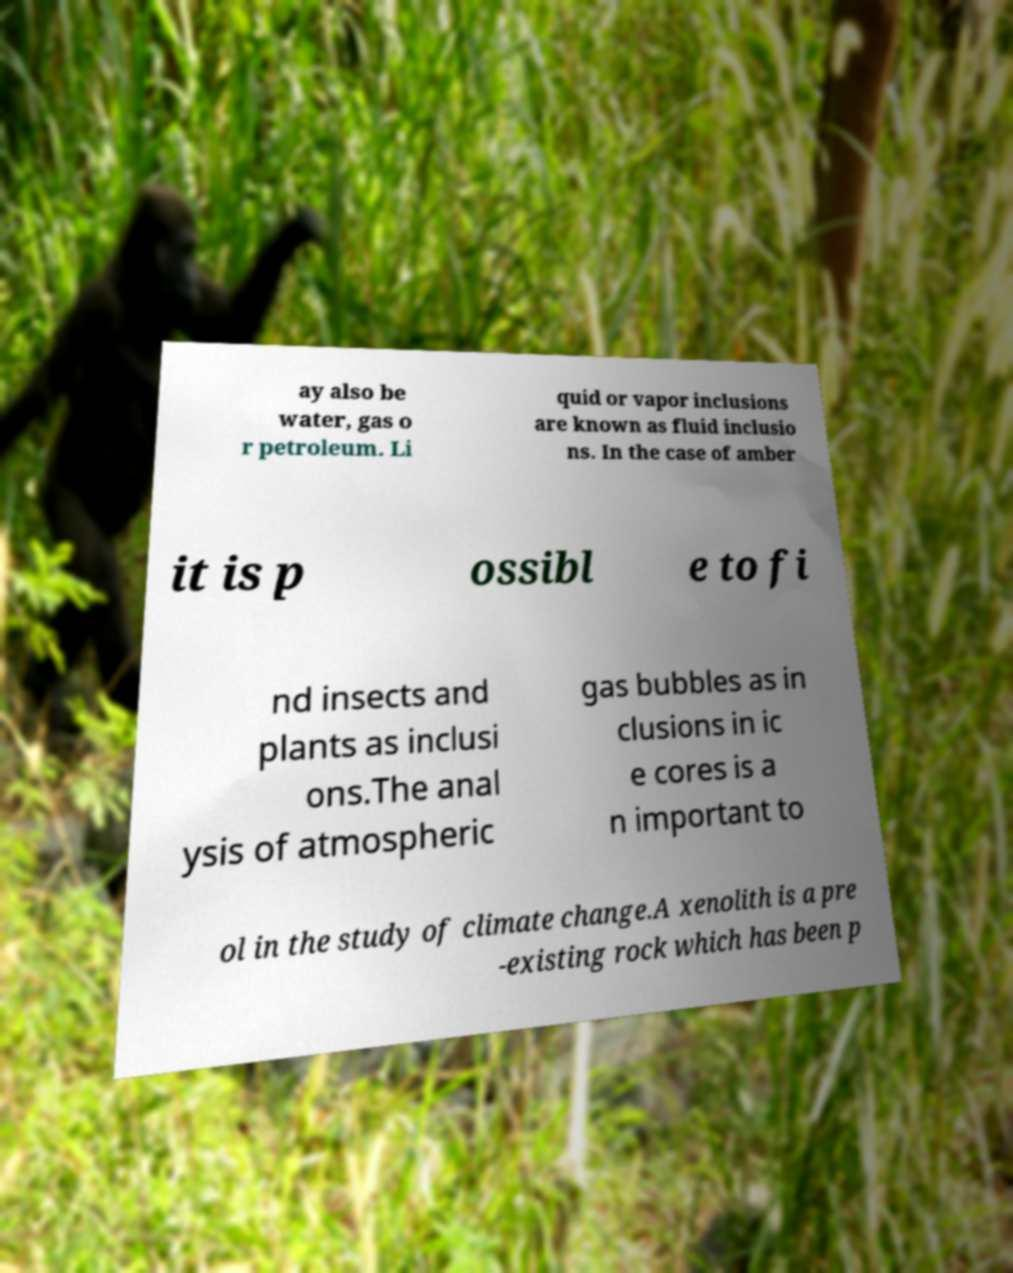I need the written content from this picture converted into text. Can you do that? ay also be water, gas o r petroleum. Li quid or vapor inclusions are known as fluid inclusio ns. In the case of amber it is p ossibl e to fi nd insects and plants as inclusi ons.The anal ysis of atmospheric gas bubbles as in clusions in ic e cores is a n important to ol in the study of climate change.A xenolith is a pre -existing rock which has been p 